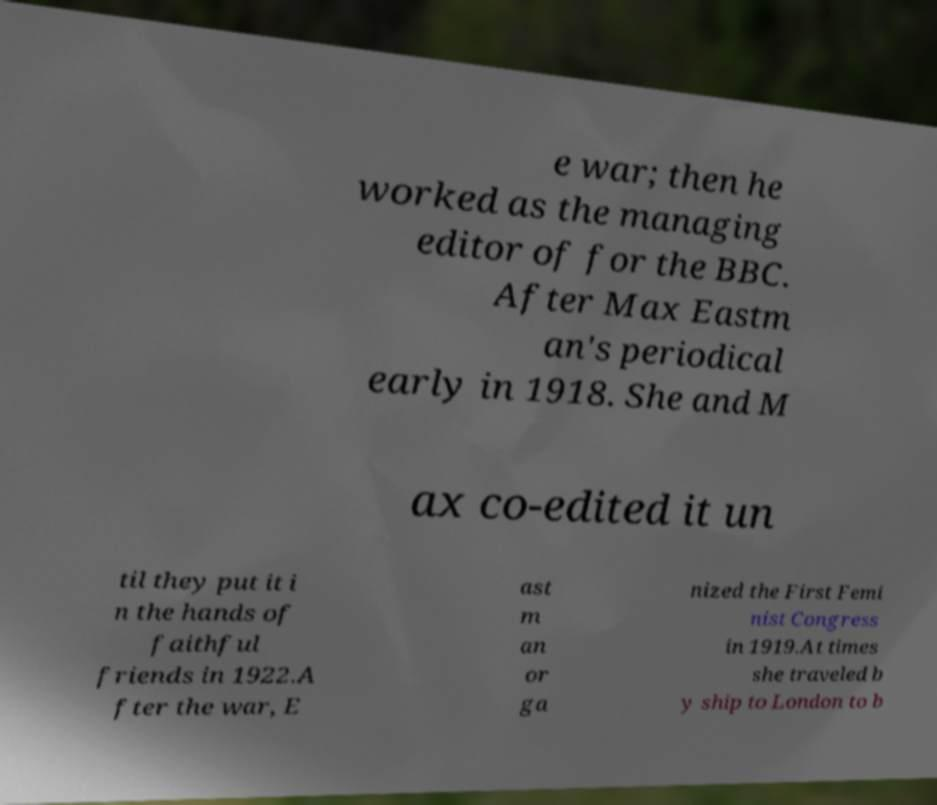Can you accurately transcribe the text from the provided image for me? e war; then he worked as the managing editor of for the BBC. After Max Eastm an's periodical early in 1918. She and M ax co-edited it un til they put it i n the hands of faithful friends in 1922.A fter the war, E ast m an or ga nized the First Femi nist Congress in 1919.At times she traveled b y ship to London to b 